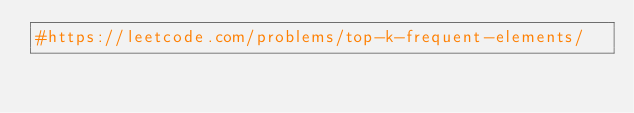<code> <loc_0><loc_0><loc_500><loc_500><_Python_>#https://leetcode.com/problems/top-k-frequent-elements/


</code> 